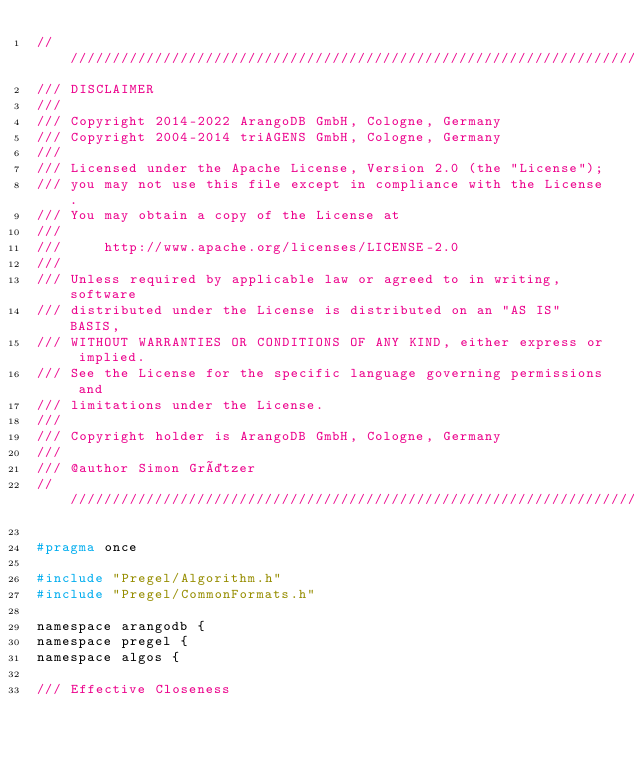<code> <loc_0><loc_0><loc_500><loc_500><_C_>////////////////////////////////////////////////////////////////////////////////
/// DISCLAIMER
///
/// Copyright 2014-2022 ArangoDB GmbH, Cologne, Germany
/// Copyright 2004-2014 triAGENS GmbH, Cologne, Germany
///
/// Licensed under the Apache License, Version 2.0 (the "License");
/// you may not use this file except in compliance with the License.
/// You may obtain a copy of the License at
///
///     http://www.apache.org/licenses/LICENSE-2.0
///
/// Unless required by applicable law or agreed to in writing, software
/// distributed under the License is distributed on an "AS IS" BASIS,
/// WITHOUT WARRANTIES OR CONDITIONS OF ANY KIND, either express or implied.
/// See the License for the specific language governing permissions and
/// limitations under the License.
///
/// Copyright holder is ArangoDB GmbH, Cologne, Germany
///
/// @author Simon Grätzer
////////////////////////////////////////////////////////////////////////////////

#pragma once

#include "Pregel/Algorithm.h"
#include "Pregel/CommonFormats.h"

namespace arangodb {
namespace pregel {
namespace algos {

/// Effective Closeness</code> 